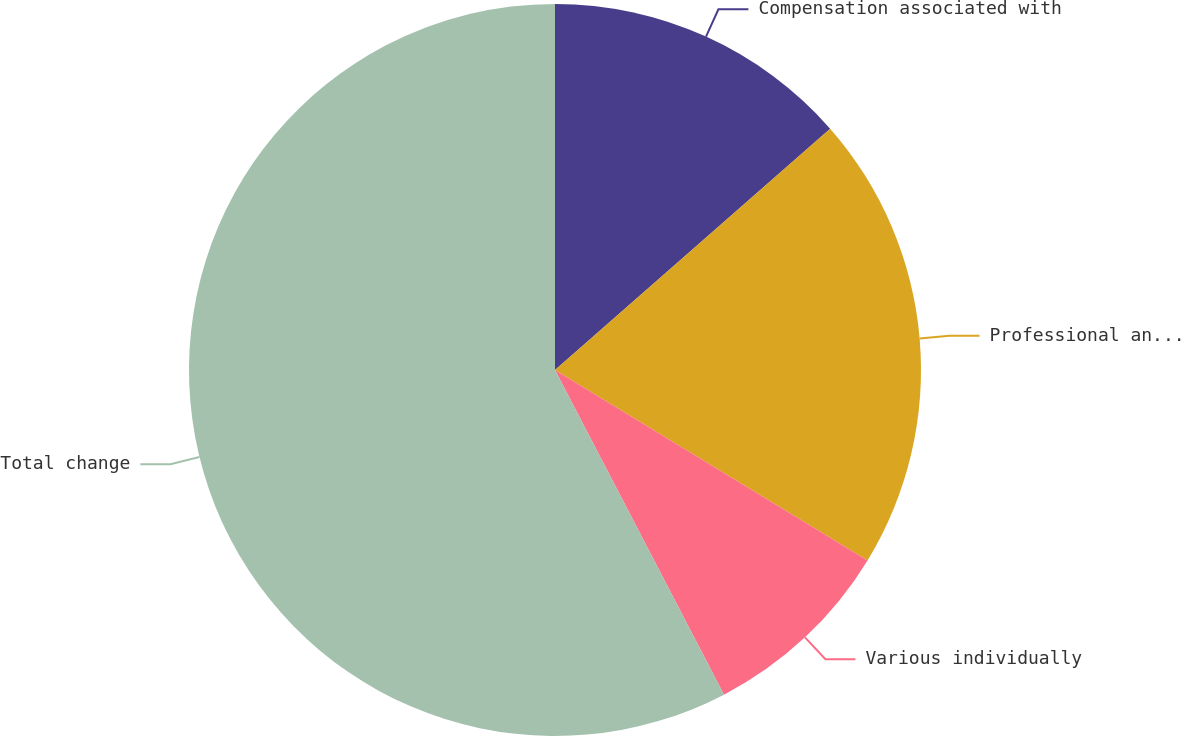Convert chart to OTSL. <chart><loc_0><loc_0><loc_500><loc_500><pie_chart><fcel>Compensation associated with<fcel>Professional and consulting<fcel>Various individually<fcel>Total change<nl><fcel>13.54%<fcel>20.17%<fcel>8.65%<fcel>57.64%<nl></chart> 